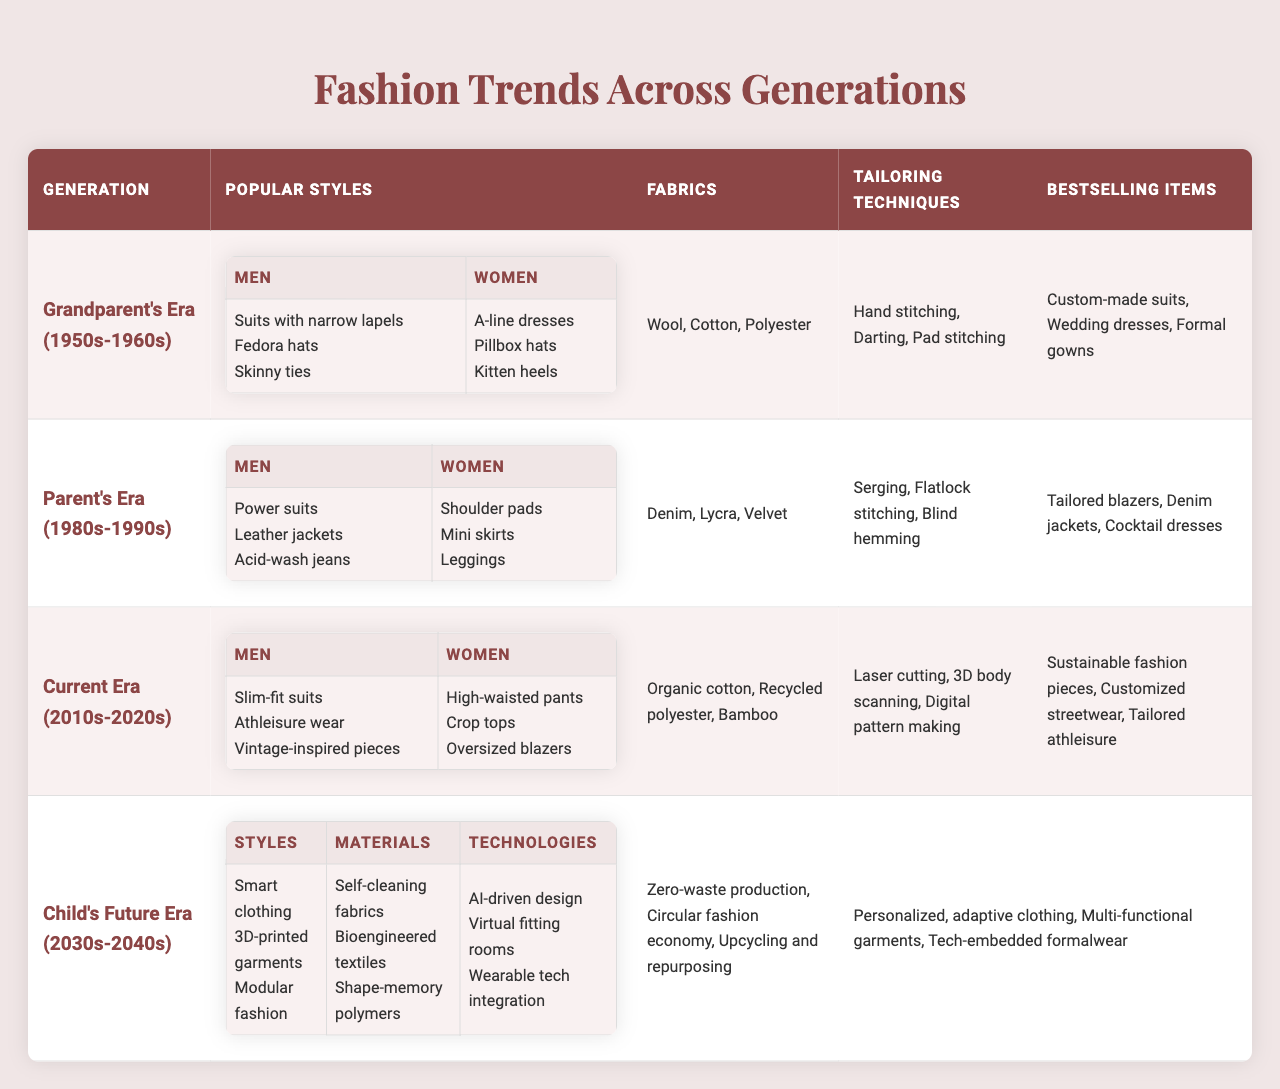What were the popular styles for men in your grandparent's era? In the table under "Grandparent's Era (1950s-1960s)," the popular styles for men include "Suits with narrow lapels," "Fedora hats," and "Skinny ties."
Answer: Suits with narrow lapels, Fedora hats, Skinny ties Which generation had the best-selling item "Tailored blazers"? Upon examining the table, "Tailored blazers" appears under the "Parent's Era (1980s-1990s)" in the "Bestselling Items" category.
Answer: Parent's Era (1980s-1990s) How many tailoring techniques are listed for the current era? The current era (2010s-2020s) lists three tailoring techniques: "Laser cutting," "3D body scanning," and "Digital pattern making," making the count equal to three.
Answer: Three Are there any sustainability focuses mentioned for the future era? The table indicates that the future era (2030s-2040s) includes sustainability focuses, such as "Zero-waste production," "Circular fashion economy," and "Upcycling and repurposing."
Answer: Yes What is the relationship between the fabrics used in your parent's era and the best-selling item "Cocktail dresses"? In the table, for the parent's era, the fabrics listed are "Denim," "Lycra," and "Velvet," and "Cocktail dresses" is a best-selling item that likely uses these fabrics, especially "Lycra" and "Velvet," which are common in cocktail attire.
Answer: Cocktail dresses use Lycra and Velvet Which generation is projected to have styles involving 3D-printed garments? The table shows that in the "Child's Future Era (2030s-2040s)," projected trends include "3D-printed garments."
Answer: Child's Future Era (2030s-2040s) From the data, what were some of the popular styles for women in the Parent's Era? According to the Parent's Era (1980s-1990s) section of the table, the popular styles for women included "Shoulder pads," "Mini skirts," and "Leggings."
Answer: Shoulder pads, Mini skirts, Leggings Comparing generations, which fabrics saw a shift towards sustainability focus by the future era? The table illustrates that the fabrics in the current era (2010s-2020s) like "Organic cotton," "Recycled polyester," and "Bamboo" shift towards sustainable materials in the future era (2030s-2040s) emphasizing sustainable practices but does not list specific fabrics for the future.
Answer: Shift towards sustainability focus What tailoring technique was primarily used in the grandparent's era? The grandparent's era (1950s-1960s) mentions "Hand stitching," considered a primary technique in tailoring during that period.
Answer: Hand stitching What do the relatively modern fabrics have in common with the projected future materials? The modern era's use of fabrics like "Organic cotton," "Recycled polyester," and "Bamboo" have a shared focus on sustainability, reflecting a trend that could influence future materials like "Bioengineered textiles" as they emphasize eco-friendliness and innovation.
Answer: Focus on sustainability and eco-friendliness 